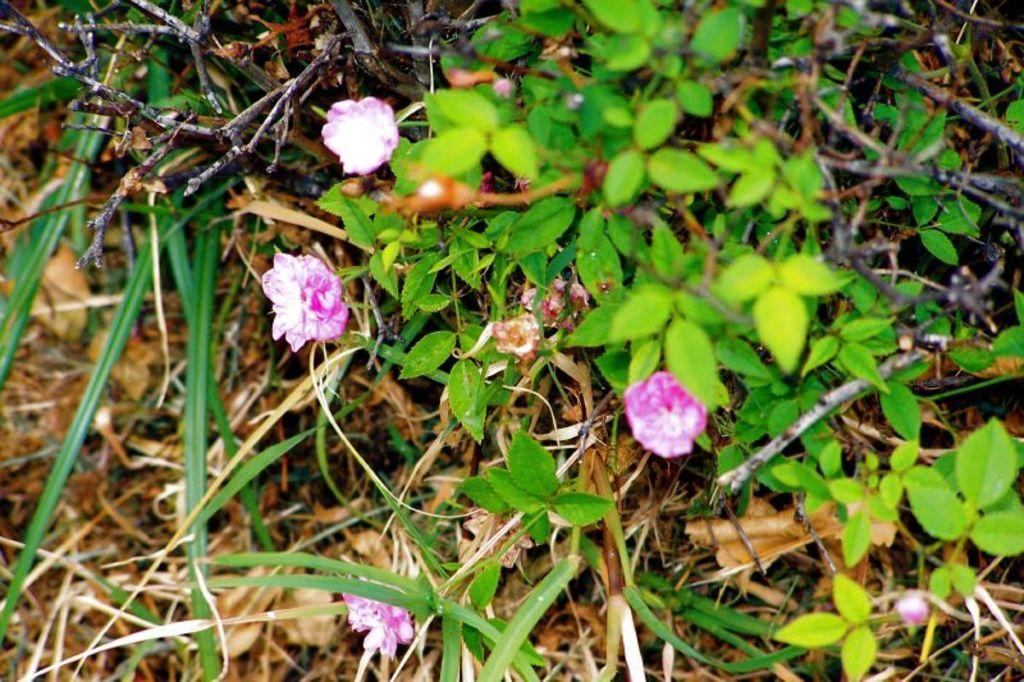Can you describe this image briefly? In this image we can see flowers and we can also see plant leaves 